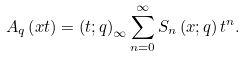<formula> <loc_0><loc_0><loc_500><loc_500>A _ { q } \left ( x t \right ) = \left ( t ; q \right ) _ { \infty } \sum _ { n = 0 } ^ { \infty } S _ { n } \left ( x ; q \right ) t ^ { n } .</formula> 